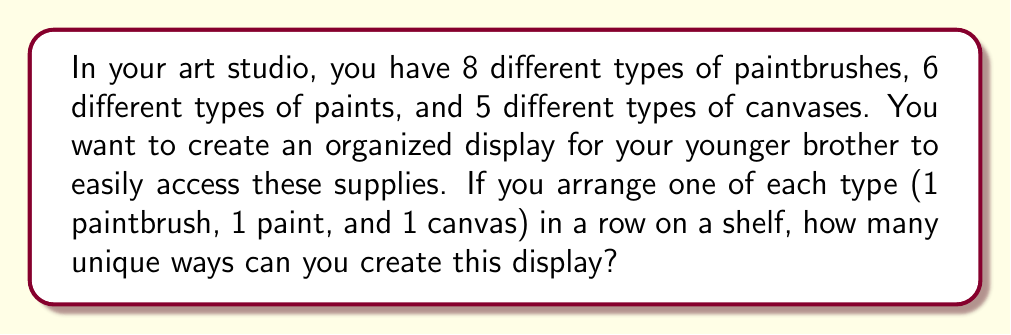Solve this math problem. Let's approach this step-by-step using the multiplication principle of counting:

1) For the paintbrush selection:
   - You have 8 different types of paintbrushes to choose from.
   - You need to select 1 paintbrush for the display.
   - This can be done in 8 ways.

2) For the paint selection:
   - You have 6 different types of paints to choose from.
   - You need to select 1 paint for the display.
   - This can be done in 6 ways.

3) For the canvas selection:
   - You have 5 different types of canvases to choose from.
   - You need to select 1 canvas for the display.
   - This can be done in 5 ways.

4) According to the multiplication principle, if we have a series of independent choices, the total number of ways to make these choices is the product of the number of ways to make each individual choice.

5) Therefore, the total number of unique ways to create the display is:

   $$ 8 \times 6 \times 5 = 240 $$

This means you can create 240 different combinations of paintbrush, paint, and canvas arrangements on the shelf for your brother.
Answer: 240 